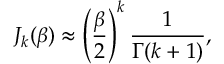<formula> <loc_0><loc_0><loc_500><loc_500>J _ { k } ( \beta ) \approx \left ( \frac { \beta } { 2 } \right ) ^ { k } \frac { 1 } { \Gamma ( k + 1 ) } ,</formula> 